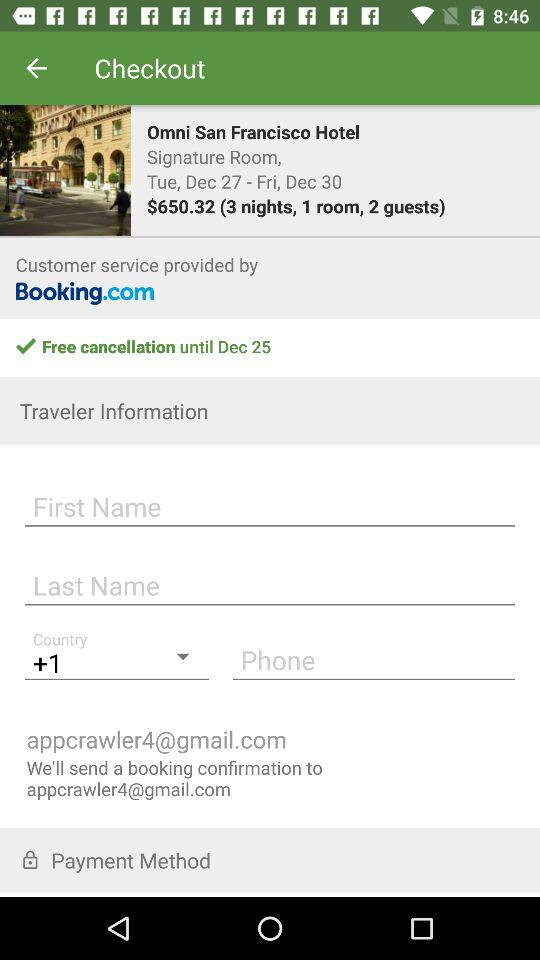How many days are the guests staying?
Answer the question using a single word or phrase. 3 